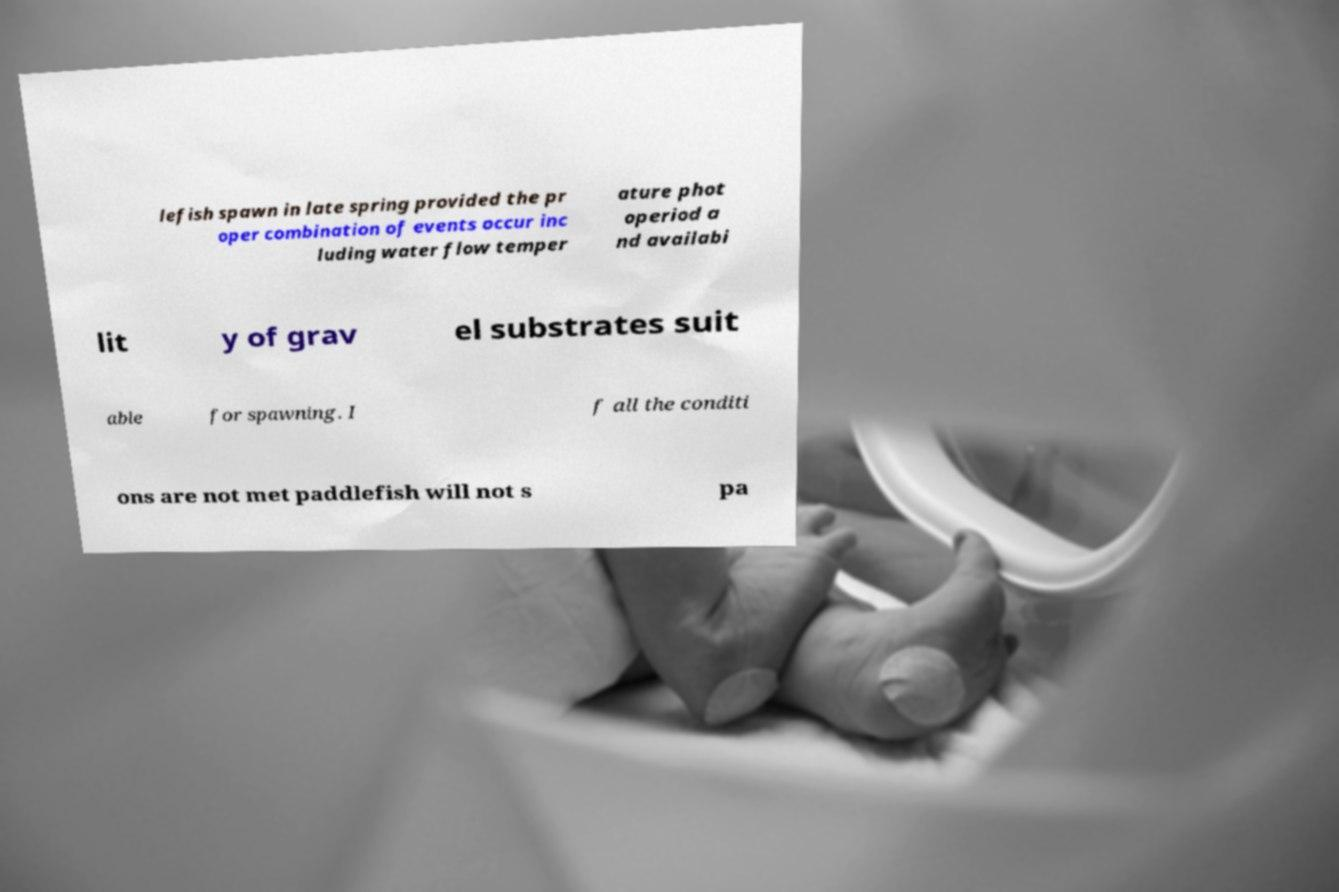Can you read and provide the text displayed in the image?This photo seems to have some interesting text. Can you extract and type it out for me? lefish spawn in late spring provided the pr oper combination of events occur inc luding water flow temper ature phot operiod a nd availabi lit y of grav el substrates suit able for spawning. I f all the conditi ons are not met paddlefish will not s pa 